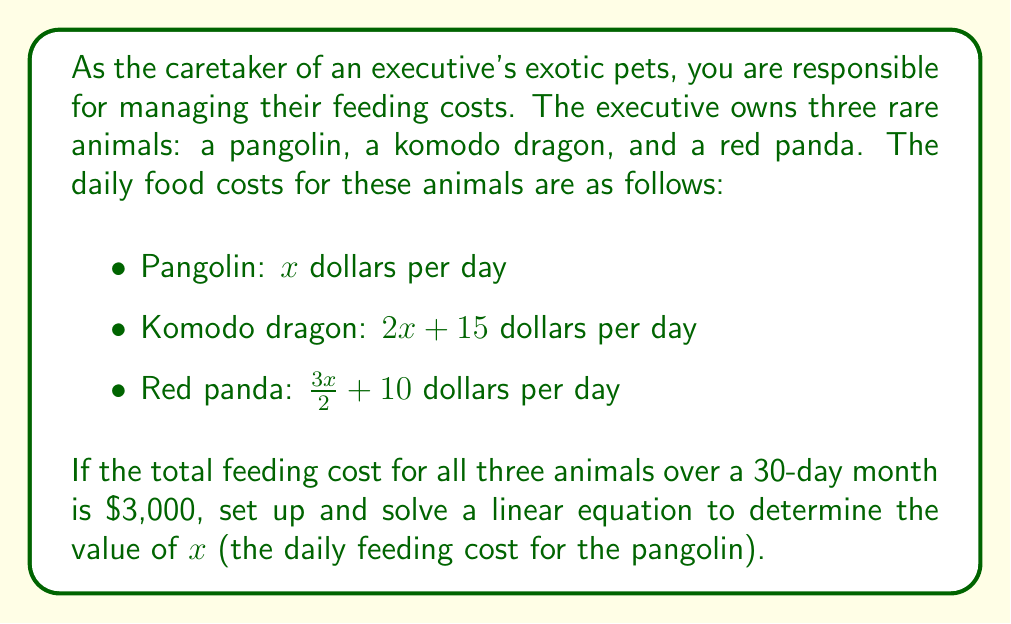Give your solution to this math problem. To solve this problem, we'll follow these steps:

1) First, let's set up an equation representing the total cost for 30 days:

   $30(x) + 30(2x + 15) + 30(\frac{3x}{2} + 10) = 3000$

2) Let's simplify the left side of the equation:

   $30x + 60x + 450 + 45x + 300 = 3000$

3) Combine like terms:

   $135x + 750 = 3000$

4) Subtract 750 from both sides:

   $135x = 2250$

5) Divide both sides by 135:

   $x = \frac{2250}{135}$

6) Simplify:

   $x = \frac{250}{15} = \frac{50}{3}$

Therefore, $x = \frac{50}{3}$ or approximately $16.67 dollars per day for the pangolin's food.
Answer: $x = \frac{50}{3}$ dollars per day 